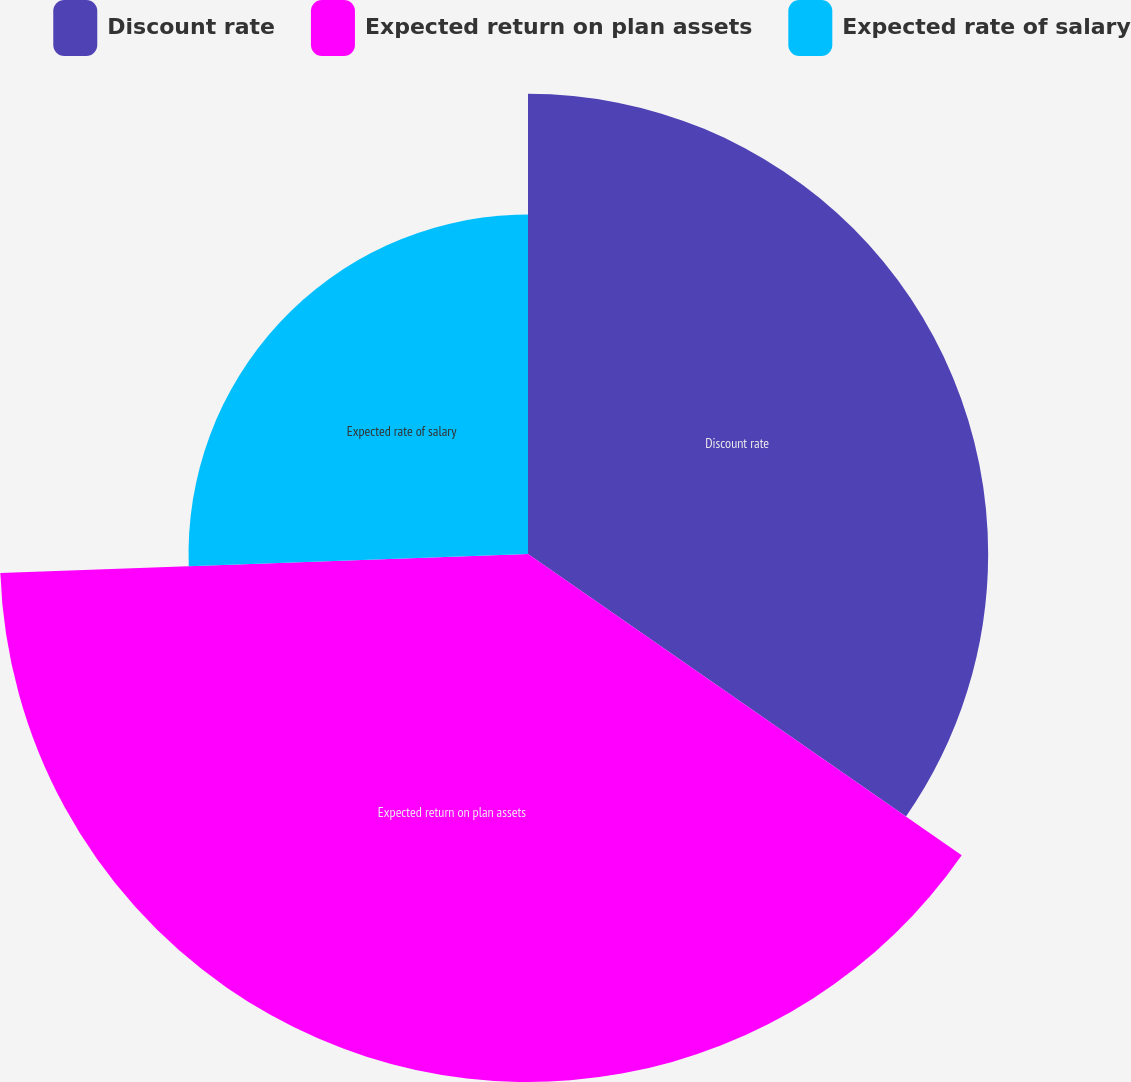<chart> <loc_0><loc_0><loc_500><loc_500><pie_chart><fcel>Discount rate<fcel>Expected return on plan assets<fcel>Expected rate of salary<nl><fcel>34.66%<fcel>39.77%<fcel>25.57%<nl></chart> 